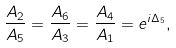<formula> <loc_0><loc_0><loc_500><loc_500>\frac { A _ { 2 } } { A _ { 5 } } = \frac { A _ { 6 } } { A _ { 3 } } = \frac { A _ { 4 } } { A _ { 1 } } = e ^ { i \Delta _ { 5 } } ,</formula> 